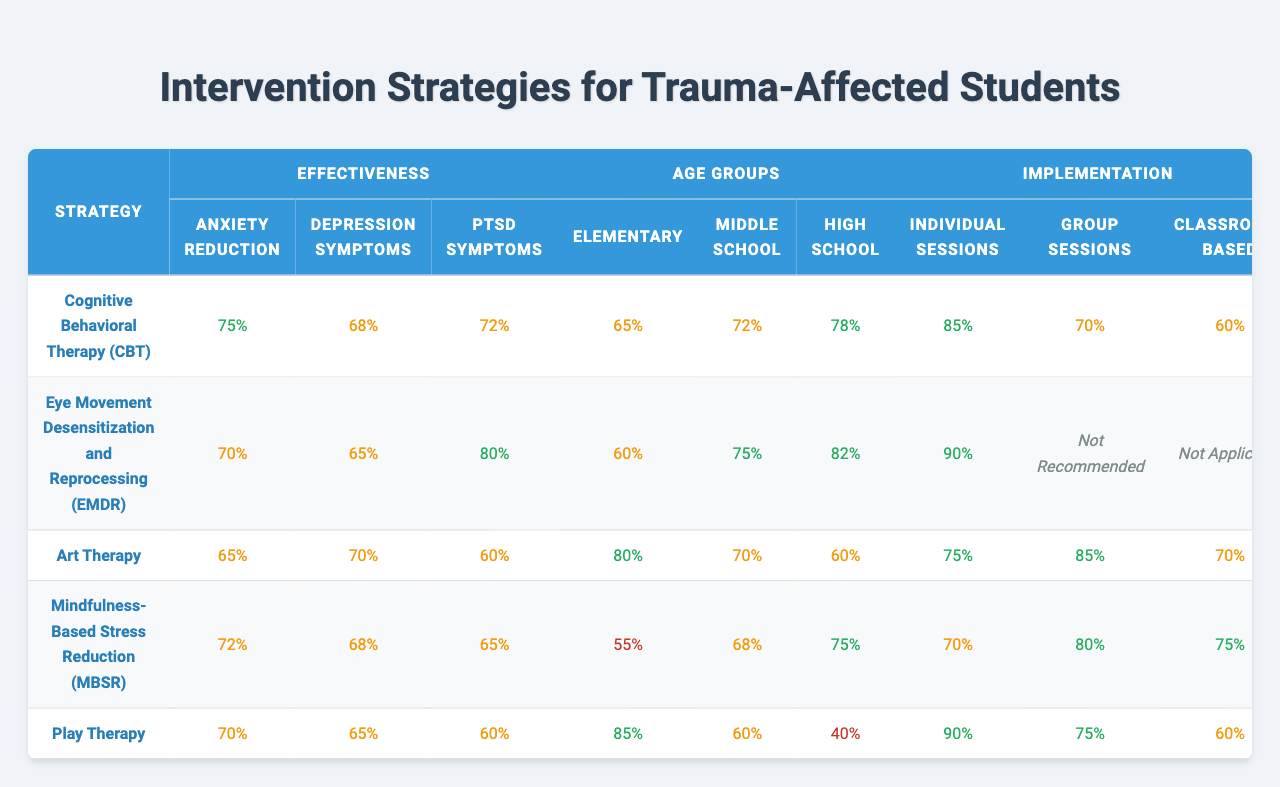What is the effectiveness percentage for PTSD symptoms using Cognitive Behavioral Therapy (CBT)? The effectiveness percentage for PTSD symptoms according to the table for Cognitive Behavioral Therapy (CBT) is listed directly as 72%.
Answer: 72% Which intervention strategy has the highest effectiveness for anxiety reduction? Upon reviewing the table, Cognitive Behavioral Therapy (CBT) has the highest effectiveness for anxiety reduction at 75%.
Answer: Cognitive Behavioral Therapy (CBT) For which age group is Art Therapy most effective? The table shows that Art Therapy is most effective for the Elementary age group, with an effectiveness of 80% in that category.
Answer: Elementary What is the implementation percentage for group sessions in Eye Movement Desensitization and Reprocessing (EMDR)? The table specifies that for Eye Movement Desensitization and Reprocessing (EMDR), group sessions are marked as "Not Recommended," meaning there is no percentage listed for effectiveness in this category.
Answer: Not Recommended How does the effectiveness of Mindfulness-Based Stress Reduction (MBSR) for depression symptoms compare to that of Play Therapy? According to the table, Mindfulness-Based Stress Reduction (MBSR) shows effectiveness of 68% for depression symptoms, while Play Therapy shows effectiveness of 65%. MBSR is therefore more effective for depression symptoms than Play Therapy.
Answer: MBSR is more effective Calculate the average effectiveness of Cognitive Behavioral Therapy (CBT) across all three effectiveness categories (anxiety reduction, depression symptoms, PTSD symptoms). The effectiveness percentages for CBT are 75% for anxiety reduction, 68% for depression symptoms, and 72% for PTSD symptoms. The average is calculated as (75 + 68 + 72) / 3 = 215 / 3 ≈ 71.67%.
Answer: Approximately 71.67% Is the effectiveness of Group Sessions for Art Therapy greater than that for CBT? The table shows that Group Sessions for Art Therapy are 85% effective while Group Sessions for CBT are 70% effective. Since 85% is greater than 70%, the statement is true.
Answer: Yes What is the lowest effectiveness percentage for PTSD symptoms among the listed intervention strategies? By reviewing the effectiveness percentages for PTSD symptoms in the table, Play Therapy has the lowest effectiveness at 60%.
Answer: 60% If we consider the effectiveness for individual sessions of all strategies, which strategy is the most effective? The table indicates effectiveness percentages for individual sessions: CBT at 85%, EMDR at 90%, Art Therapy at 75%, MBSR at 70%, and Play Therapy at 90%. EMDR and Play Therapy are tied at 90% for individual sessions.
Answer: EMDR and Play Therapy (tied at 90%) What percentage of Middle School students responds positively to the implementation of MBSR? The table shows that the effectiveness of MBSR for Middle School students is 68%.
Answer: 68% Which strategy is least effective in reducing anxiety based on the table? The table provides effectiveness percentages for anxiety reduction: CBT at 75%, EMDR at 70%, Art Therapy at 65%, MBSR at 72%, and Play Therapy at 70%. Art Therapy is least effective at 65%.
Answer: Art Therapy 